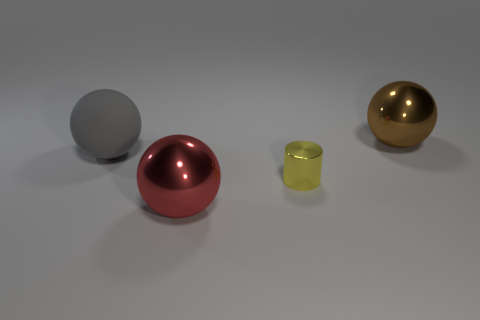Add 4 tiny yellow objects. How many objects exist? 8 Subtract all balls. How many objects are left? 1 Subtract 0 green cylinders. How many objects are left? 4 Subtract all tiny gray shiny things. Subtract all gray objects. How many objects are left? 3 Add 4 large gray rubber spheres. How many large gray rubber spheres are left? 5 Add 2 big brown spheres. How many big brown spheres exist? 3 